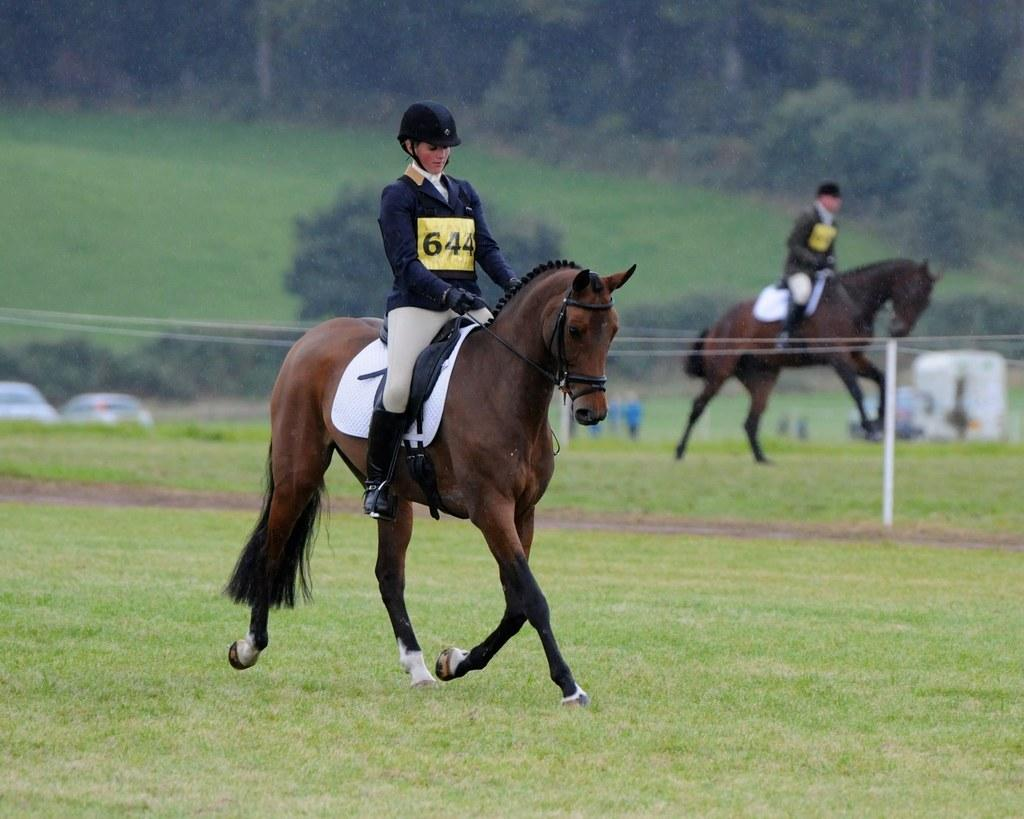Who is the main subject in the image? There is a woman in the image. What is the woman doing in the image? The woman is sitting on a brown horse and riding it. Where is the horse and rider located? The horse and rider are on the ground. What can be seen in the background of the image? There is a grass lawn and trees in the background. What type of profit can be seen in the image? There is no profit visible in the image; it features a woman riding a brown horse on a grass lawn with trees in the background. How many dogs are present in the image? There are no dogs present in the image. 